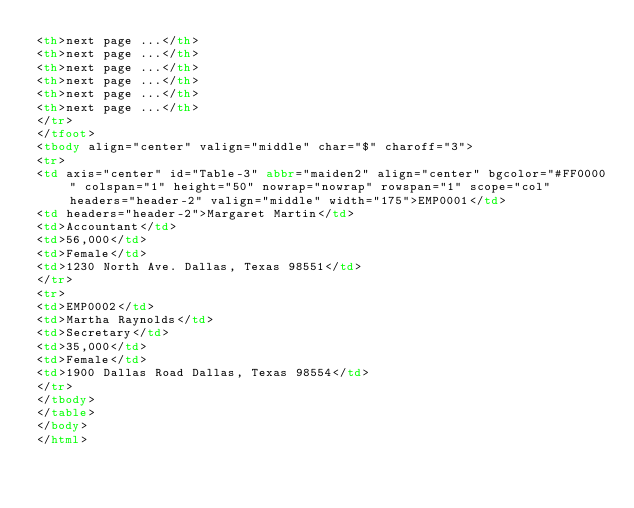Convert code to text. <code><loc_0><loc_0><loc_500><loc_500><_HTML_><th>next page ...</th>
<th>next page ...</th>
<th>next page ...</th>
<th>next page ...</th>
<th>next page ...</th>
<th>next page ...</th>
</tr>
</tfoot>
<tbody align="center" valign="middle" char="$" charoff="3">
<tr>
<td axis="center" id="Table-3" abbr="maiden2" align="center" bgcolor="#FF0000" colspan="1" height="50" nowrap="nowrap" rowspan="1" scope="col" headers="header-2" valign="middle" width="175">EMP0001</td>
<td headers="header-2">Margaret Martin</td>
<td>Accountant</td>
<td>56,000</td>
<td>Female</td>
<td>1230 North Ave. Dallas, Texas 98551</td>
</tr>
<tr>
<td>EMP0002</td>
<td>Martha Raynolds</td>
<td>Secretary</td>
<td>35,000</td>
<td>Female</td>
<td>1900 Dallas Road Dallas, Texas 98554</td>
</tr>
</tbody>
</table>
</body>
</html>



</code> 